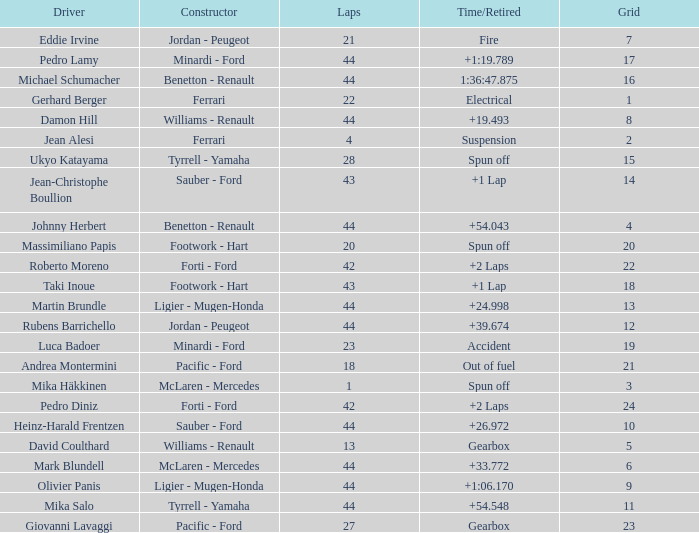Could you parse the entire table as a dict? {'header': ['Driver', 'Constructor', 'Laps', 'Time/Retired', 'Grid'], 'rows': [['Eddie Irvine', 'Jordan - Peugeot', '21', 'Fire', '7'], ['Pedro Lamy', 'Minardi - Ford', '44', '+1:19.789', '17'], ['Michael Schumacher', 'Benetton - Renault', '44', '1:36:47.875', '16'], ['Gerhard Berger', 'Ferrari', '22', 'Electrical', '1'], ['Damon Hill', 'Williams - Renault', '44', '+19.493', '8'], ['Jean Alesi', 'Ferrari', '4', 'Suspension', '2'], ['Ukyo Katayama', 'Tyrrell - Yamaha', '28', 'Spun off', '15'], ['Jean-Christophe Boullion', 'Sauber - Ford', '43', '+1 Lap', '14'], ['Johnny Herbert', 'Benetton - Renault', '44', '+54.043', '4'], ['Massimiliano Papis', 'Footwork - Hart', '20', 'Spun off', '20'], ['Roberto Moreno', 'Forti - Ford', '42', '+2 Laps', '22'], ['Taki Inoue', 'Footwork - Hart', '43', '+1 Lap', '18'], ['Martin Brundle', 'Ligier - Mugen-Honda', '44', '+24.998', '13'], ['Rubens Barrichello', 'Jordan - Peugeot', '44', '+39.674', '12'], ['Luca Badoer', 'Minardi - Ford', '23', 'Accident', '19'], ['Andrea Montermini', 'Pacific - Ford', '18', 'Out of fuel', '21'], ['Mika Häkkinen', 'McLaren - Mercedes', '1', 'Spun off', '3'], ['Pedro Diniz', 'Forti - Ford', '42', '+2 Laps', '24'], ['Heinz-Harald Frentzen', 'Sauber - Ford', '44', '+26.972', '10'], ['David Coulthard', 'Williams - Renault', '13', 'Gearbox', '5'], ['Mark Blundell', 'McLaren - Mercedes', '44', '+33.772', '6'], ['Olivier Panis', 'Ligier - Mugen-Honda', '44', '+1:06.170', '9'], ['Mika Salo', 'Tyrrell - Yamaha', '44', '+54.548', '11'], ['Giovanni Lavaggi', 'Pacific - Ford', '27', 'Gearbox', '23']]} Who built the car that ran out of fuel before 28 laps? Pacific - Ford. 